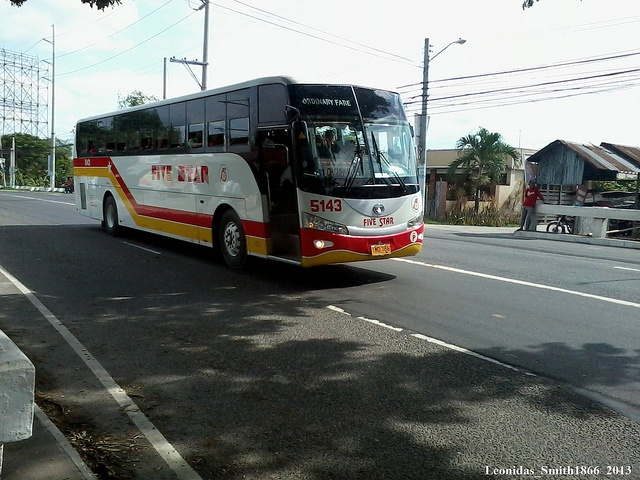Describe the objects in this image and their specific colors. I can see bus in white, black, gray, darkgray, and maroon tones, people in white, black, maroon, gray, and purple tones, people in white, black, gray, and purple tones, motorcycle in white, black, gray, darkgray, and lightgray tones, and people in white, black, gray, darkgreen, and teal tones in this image. 